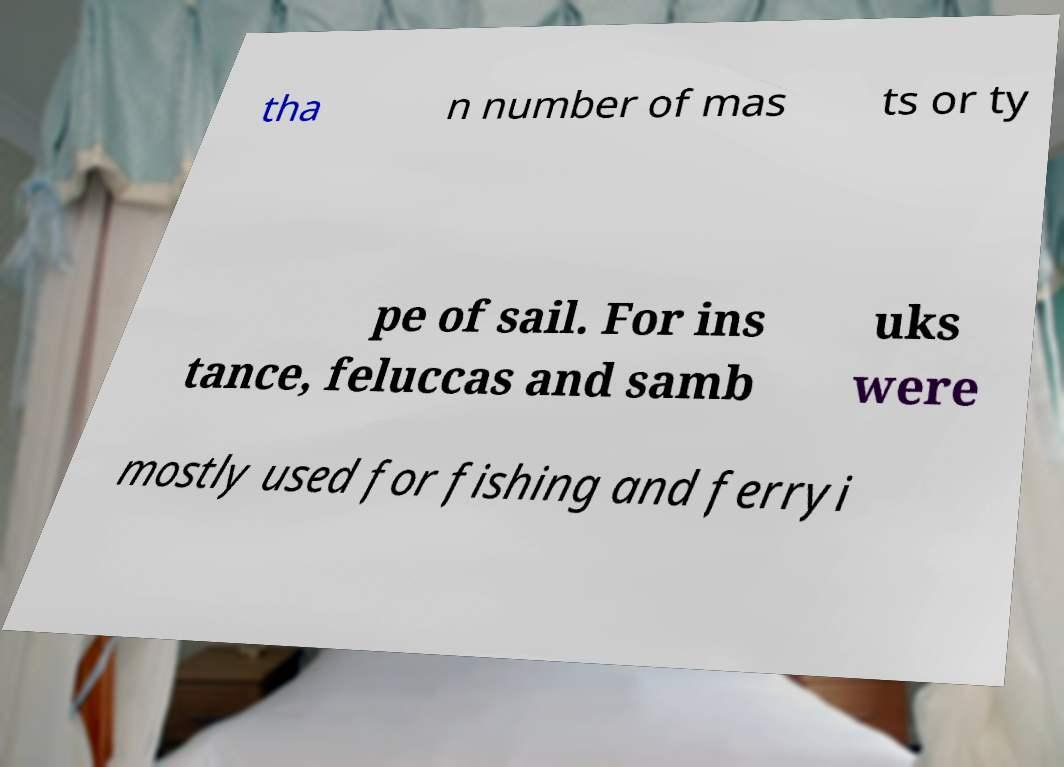I need the written content from this picture converted into text. Can you do that? tha n number of mas ts or ty pe of sail. For ins tance, feluccas and samb uks were mostly used for fishing and ferryi 